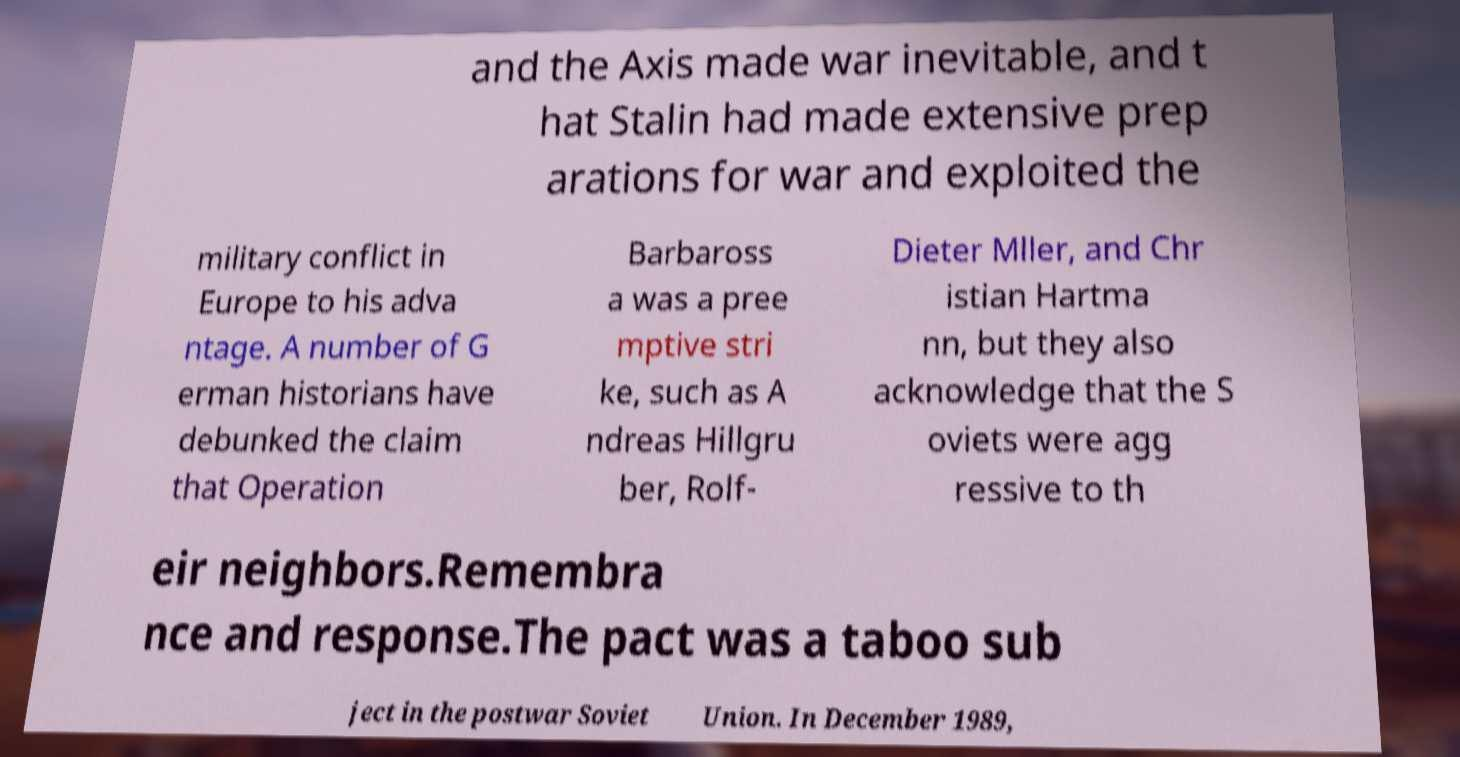What messages or text are displayed in this image? I need them in a readable, typed format. and the Axis made war inevitable, and t hat Stalin had made extensive prep arations for war and exploited the military conflict in Europe to his adva ntage. A number of G erman historians have debunked the claim that Operation Barbaross a was a pree mptive stri ke, such as A ndreas Hillgru ber, Rolf- Dieter Mller, and Chr istian Hartma nn, but they also acknowledge that the S oviets were agg ressive to th eir neighbors.Remembra nce and response.The pact was a taboo sub ject in the postwar Soviet Union. In December 1989, 